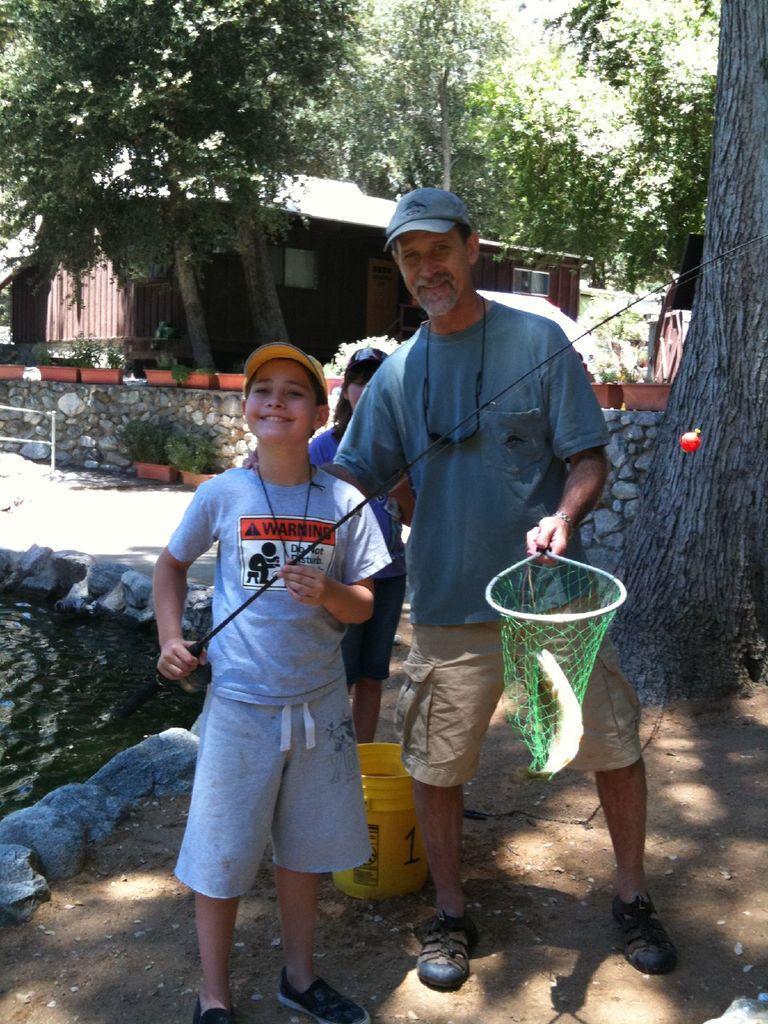In one or two sentences, can you explain what this image depicts? There is a boy wearing a cap and holding a fishing rod. Near to him a person is holding a net with fish. Also wearing a cap. On the left side there is a pond with stones on the side. In the background there is a building, trees, pots with plants, brick wall. Also there is a child in the back. And there is a yellow bucket on the ground. 